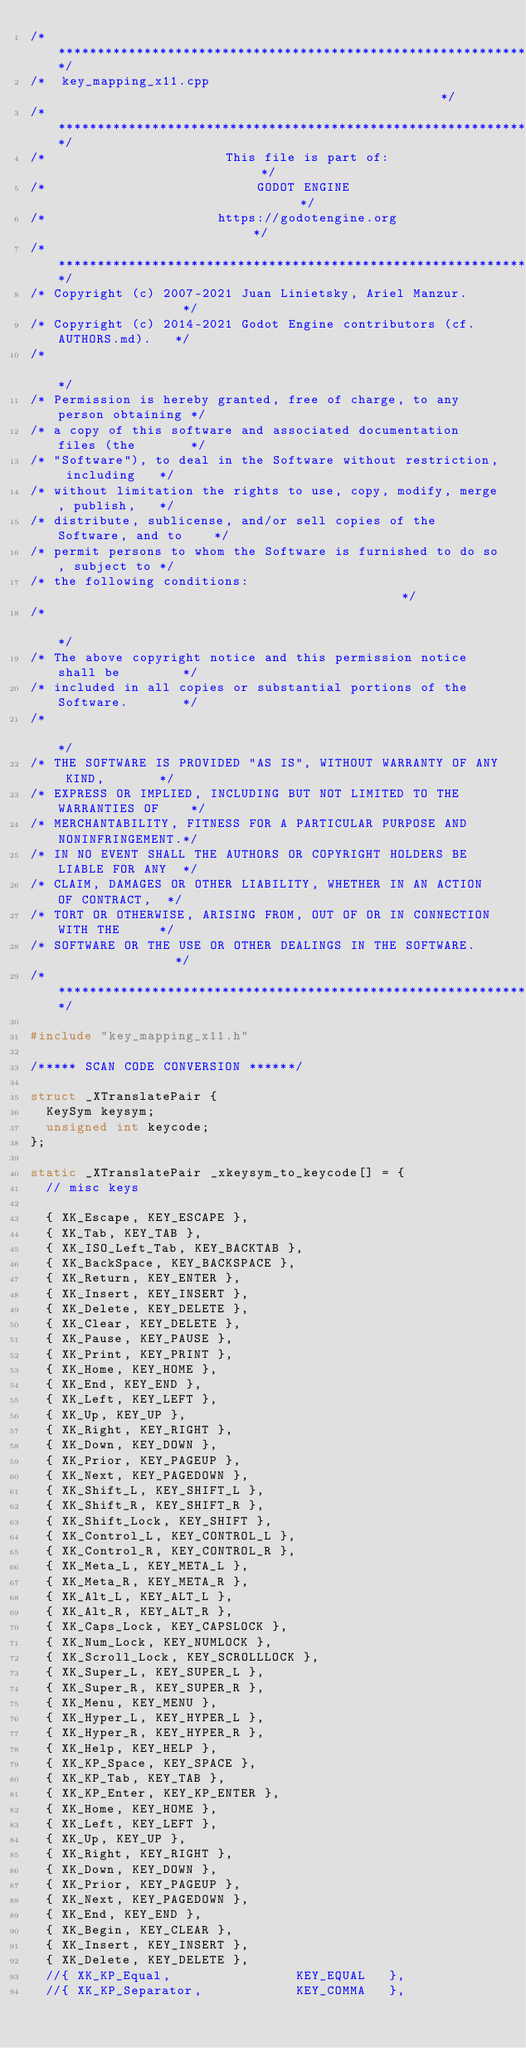<code> <loc_0><loc_0><loc_500><loc_500><_C++_>/*************************************************************************/
/*  key_mapping_x11.cpp                                                  */
/*************************************************************************/
/*                       This file is part of:                           */
/*                           GODOT ENGINE                                */
/*                      https://godotengine.org                          */
/*************************************************************************/
/* Copyright (c) 2007-2021 Juan Linietsky, Ariel Manzur.                 */
/* Copyright (c) 2014-2021 Godot Engine contributors (cf. AUTHORS.md).   */
/*                                                                       */
/* Permission is hereby granted, free of charge, to any person obtaining */
/* a copy of this software and associated documentation files (the       */
/* "Software"), to deal in the Software without restriction, including   */
/* without limitation the rights to use, copy, modify, merge, publish,   */
/* distribute, sublicense, and/or sell copies of the Software, and to    */
/* permit persons to whom the Software is furnished to do so, subject to */
/* the following conditions:                                             */
/*                                                                       */
/* The above copyright notice and this permission notice shall be        */
/* included in all copies or substantial portions of the Software.       */
/*                                                                       */
/* THE SOFTWARE IS PROVIDED "AS IS", WITHOUT WARRANTY OF ANY KIND,       */
/* EXPRESS OR IMPLIED, INCLUDING BUT NOT LIMITED TO THE WARRANTIES OF    */
/* MERCHANTABILITY, FITNESS FOR A PARTICULAR PURPOSE AND NONINFRINGEMENT.*/
/* IN NO EVENT SHALL THE AUTHORS OR COPYRIGHT HOLDERS BE LIABLE FOR ANY  */
/* CLAIM, DAMAGES OR OTHER LIABILITY, WHETHER IN AN ACTION OF CONTRACT,  */
/* TORT OR OTHERWISE, ARISING FROM, OUT OF OR IN CONNECTION WITH THE     */
/* SOFTWARE OR THE USE OR OTHER DEALINGS IN THE SOFTWARE.                */
/*************************************************************************/

#include "key_mapping_x11.h"

/***** SCAN CODE CONVERSION ******/

struct _XTranslatePair {
	KeySym keysym;
	unsigned int keycode;
};

static _XTranslatePair _xkeysym_to_keycode[] = {
	// misc keys

	{ XK_Escape, KEY_ESCAPE },
	{ XK_Tab, KEY_TAB },
	{ XK_ISO_Left_Tab, KEY_BACKTAB },
	{ XK_BackSpace, KEY_BACKSPACE },
	{ XK_Return, KEY_ENTER },
	{ XK_Insert, KEY_INSERT },
	{ XK_Delete, KEY_DELETE },
	{ XK_Clear, KEY_DELETE },
	{ XK_Pause, KEY_PAUSE },
	{ XK_Print, KEY_PRINT },
	{ XK_Home, KEY_HOME },
	{ XK_End, KEY_END },
	{ XK_Left, KEY_LEFT },
	{ XK_Up, KEY_UP },
	{ XK_Right, KEY_RIGHT },
	{ XK_Down, KEY_DOWN },
	{ XK_Prior, KEY_PAGEUP },
	{ XK_Next, KEY_PAGEDOWN },
	{ XK_Shift_L, KEY_SHIFT_L },
	{ XK_Shift_R, KEY_SHIFT_R },
	{ XK_Shift_Lock, KEY_SHIFT },
	{ XK_Control_L, KEY_CONTROL_L },
	{ XK_Control_R, KEY_CONTROL_R },
	{ XK_Meta_L, KEY_META_L },
	{ XK_Meta_R, KEY_META_R },
	{ XK_Alt_L, KEY_ALT_L },
	{ XK_Alt_R, KEY_ALT_R },
	{ XK_Caps_Lock, KEY_CAPSLOCK },
	{ XK_Num_Lock, KEY_NUMLOCK },
	{ XK_Scroll_Lock, KEY_SCROLLLOCK },
	{ XK_Super_L, KEY_SUPER_L },
	{ XK_Super_R, KEY_SUPER_R },
	{ XK_Menu, KEY_MENU },
	{ XK_Hyper_L, KEY_HYPER_L },
	{ XK_Hyper_R, KEY_HYPER_R },
	{ XK_Help, KEY_HELP },
	{ XK_KP_Space, KEY_SPACE },
	{ XK_KP_Tab, KEY_TAB },
	{ XK_KP_Enter, KEY_KP_ENTER },
	{ XK_Home, KEY_HOME },
	{ XK_Left, KEY_LEFT },
	{ XK_Up, KEY_UP },
	{ XK_Right, KEY_RIGHT },
	{ XK_Down, KEY_DOWN },
	{ XK_Prior, KEY_PAGEUP },
	{ XK_Next, KEY_PAGEDOWN },
	{ XK_End, KEY_END },
	{ XK_Begin, KEY_CLEAR },
	{ XK_Insert, KEY_INSERT },
	{ XK_Delete, KEY_DELETE },
	//{ XK_KP_Equal,                KEY_EQUAL   },
	//{ XK_KP_Separator,            KEY_COMMA   },</code> 